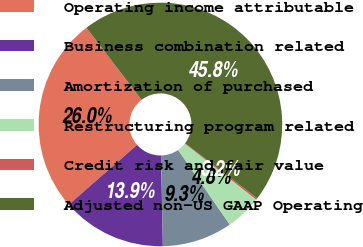<chart> <loc_0><loc_0><loc_500><loc_500><pie_chart><fcel>Operating income attributable<fcel>Business combination related<fcel>Amortization of purchased<fcel>Restructuring program related<fcel>Credit risk and fair value<fcel>Adjusted non-US GAAP Operating<nl><fcel>26.04%<fcel>13.88%<fcel>9.32%<fcel>4.77%<fcel>0.21%<fcel>45.78%<nl></chart> 